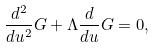Convert formula to latex. <formula><loc_0><loc_0><loc_500><loc_500>\frac { d ^ { 2 } } { d u ^ { 2 } } G + \Lambda \frac { d } { d u } G = 0 ,</formula> 